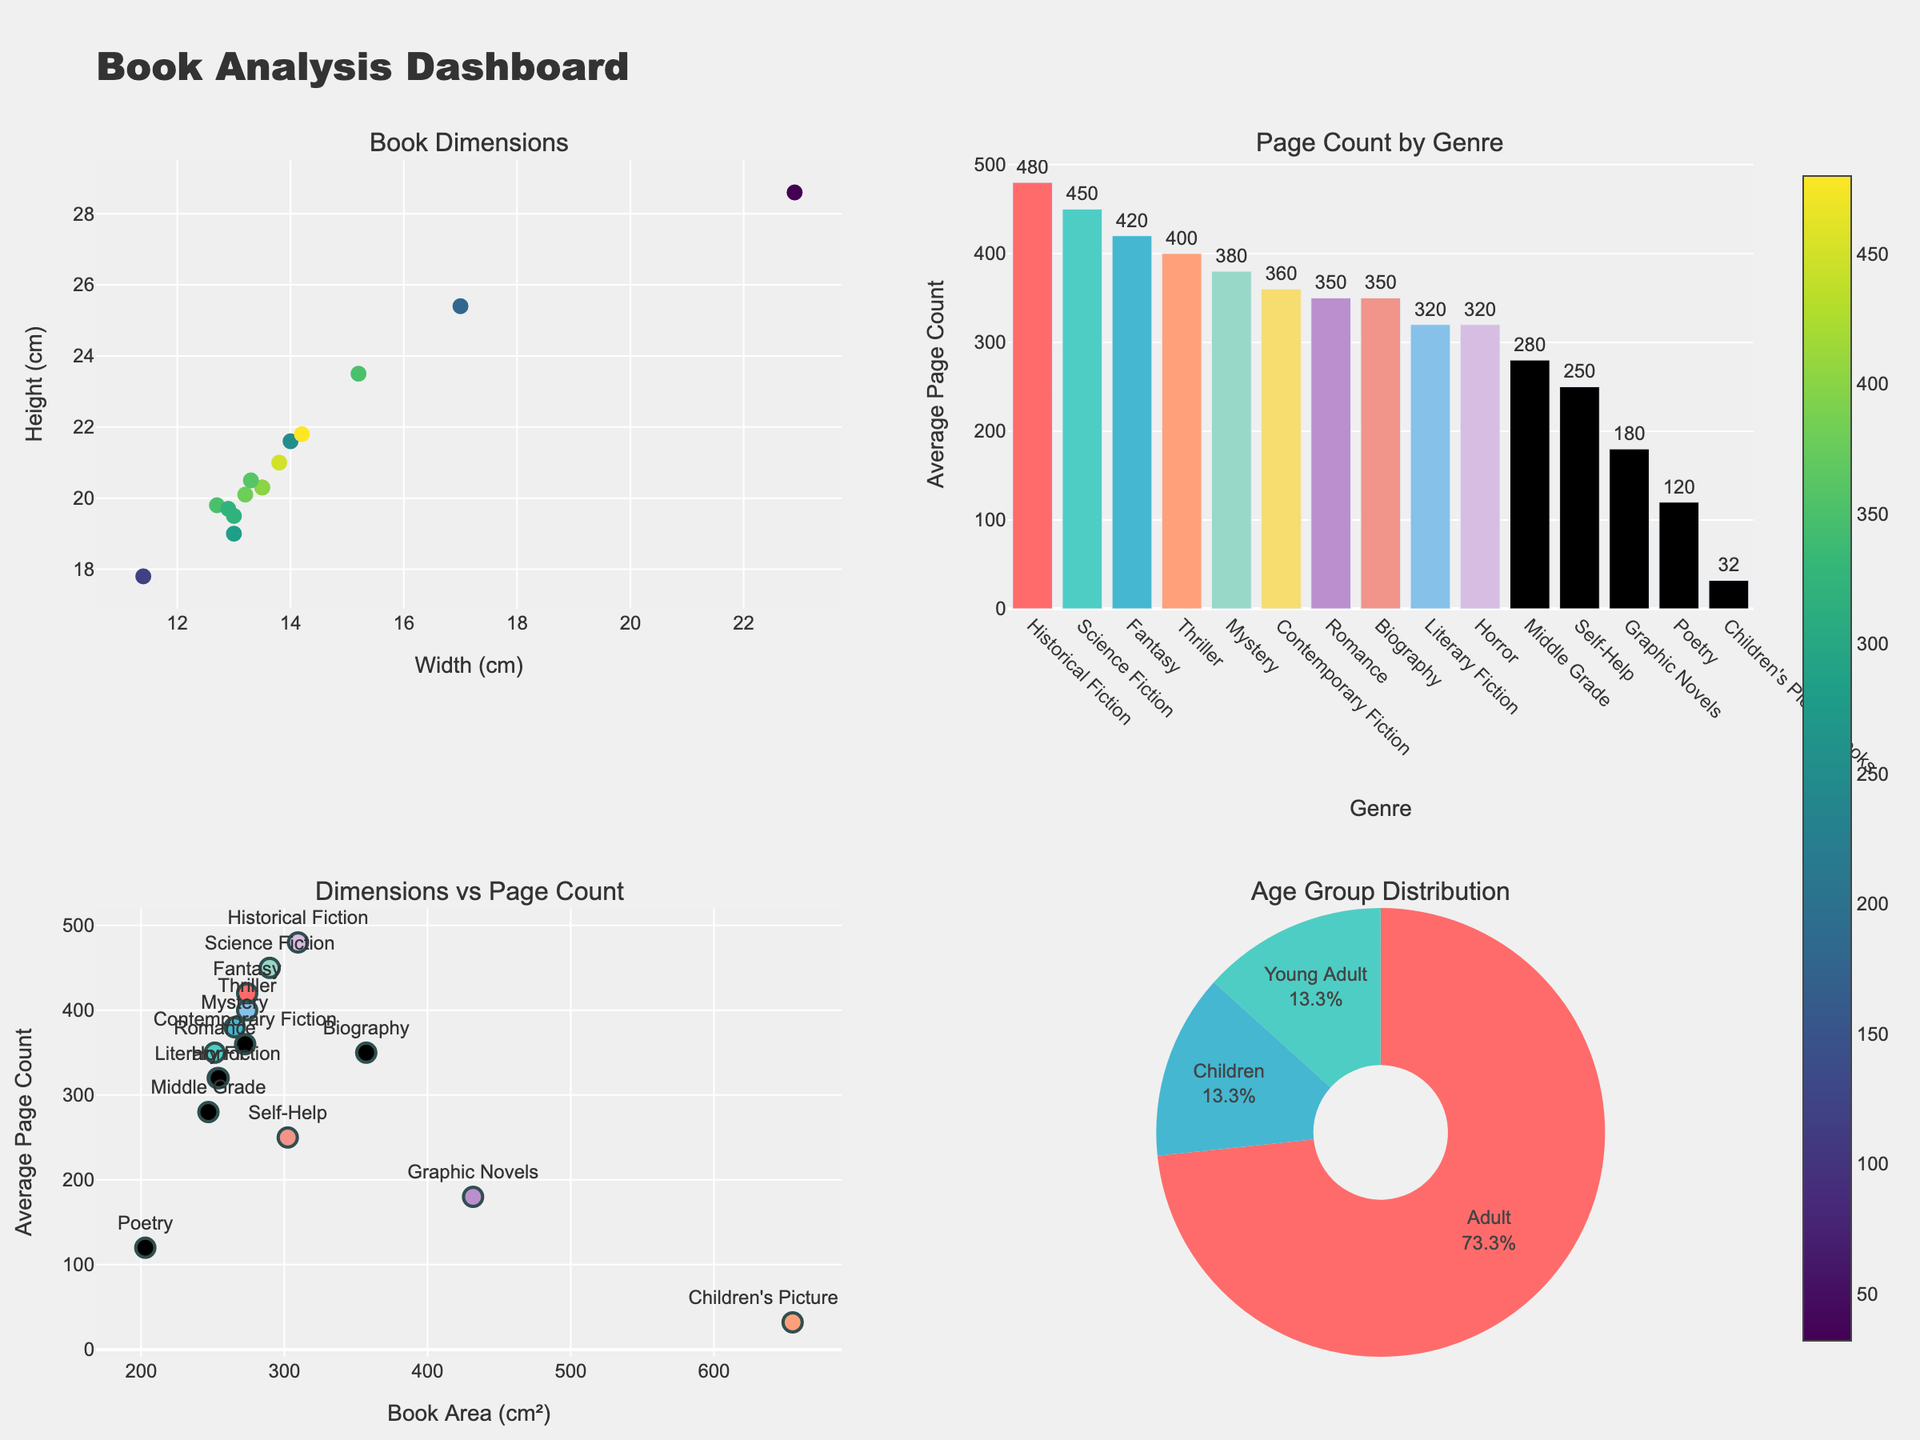How many genres are depicted in the 'Page Count by Genre' bar chart? To find the number of genres, count the number of bars in the 'Page Count by Genre' bar chart. There are 14 genres represented.
Answer: 14 Which genre has the highest average page count? Look at the 'Page Count by Genre' bar chart and identify the bar that reaches the highest point. The genre with the highest average page count is 'Historical Fiction' with an average of 480 pages.
Answer: Historical Fiction Is there a correlation between book area (width × height) and average page count? Observe the 'Dimensions vs Page Count' scatter plot. The data points do not form a strong trend line, suggesting no clear correlation between book area and average page count.
Answer: No clear correlation Are any genres exclusively present in the 'Children' age group? Check both the 'Page Count by Genre' bar chart and the 'Age Group Distribution' pie chart. 'Children's Picture Books' and 'Middle Grade' belong exclusively to the 'Children' age group.
Answer: Yes, two genres What is the average page count for 'Science Fiction' books? Refer to the 'Page Count by Genre' bar chart and look at the bar for 'Science Fiction'. The text above or beside the bar shows that 'Science Fiction' books have an average page count of 450.
Answer: 450 Which genre has the smallest average width? From the 'Book Dimensions' scatter plot, identify the point with the smallest x-value (width). The smallest average width belongs to 'Poetry', which is 11.4 cm.
Answer: Poetry Compare the average heights of 'Fantasy' and 'Mystery' genres. Which one is taller? Look at the 'Book Dimensions' scatter plot. Find the points for 'Fantasy' and 'Mystery' genres and compare their y-values (heights). 'Fantasy' has an average height of 20.3 cm, and 'Mystery' has 20.1 cm. 'Fantasy' is slightly taller.
Answer: Fantasy What is the average page count of all genres combined? Sum the average page counts for all genres and divide by the number of genres. (420 + 350 + 380 + 32 + 450 + 320 + 180 + 250 + 400 + 480 + 280 + 350 + 320 + 360 + 120) = 4692. Divide by 15 genres to get the average page count. 4692 / 15 = 312.8.
Answer: 312.8 